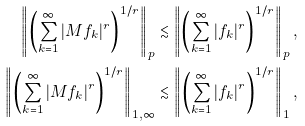<formula> <loc_0><loc_0><loc_500><loc_500>\left \| \left ( \sum _ { k = 1 } ^ { \infty } | M f _ { k } | ^ { r } \right ) ^ { 1 / r } \right \| _ { p } \lesssim \left \| \left ( \sum _ { k = 1 } ^ { \infty } | f _ { k } | ^ { r } \right ) ^ { 1 / r } \right \| _ { p } , \\ \left \| \left ( \sum _ { k = 1 } ^ { \infty } | M f _ { k } | ^ { r } \right ) ^ { 1 / r } \right \| _ { 1 , \infty } \lesssim \left \| \left ( \sum _ { k = 1 } ^ { \infty } | f _ { k } | ^ { r } \right ) ^ { 1 / r } \right \| _ { 1 } ,</formula> 